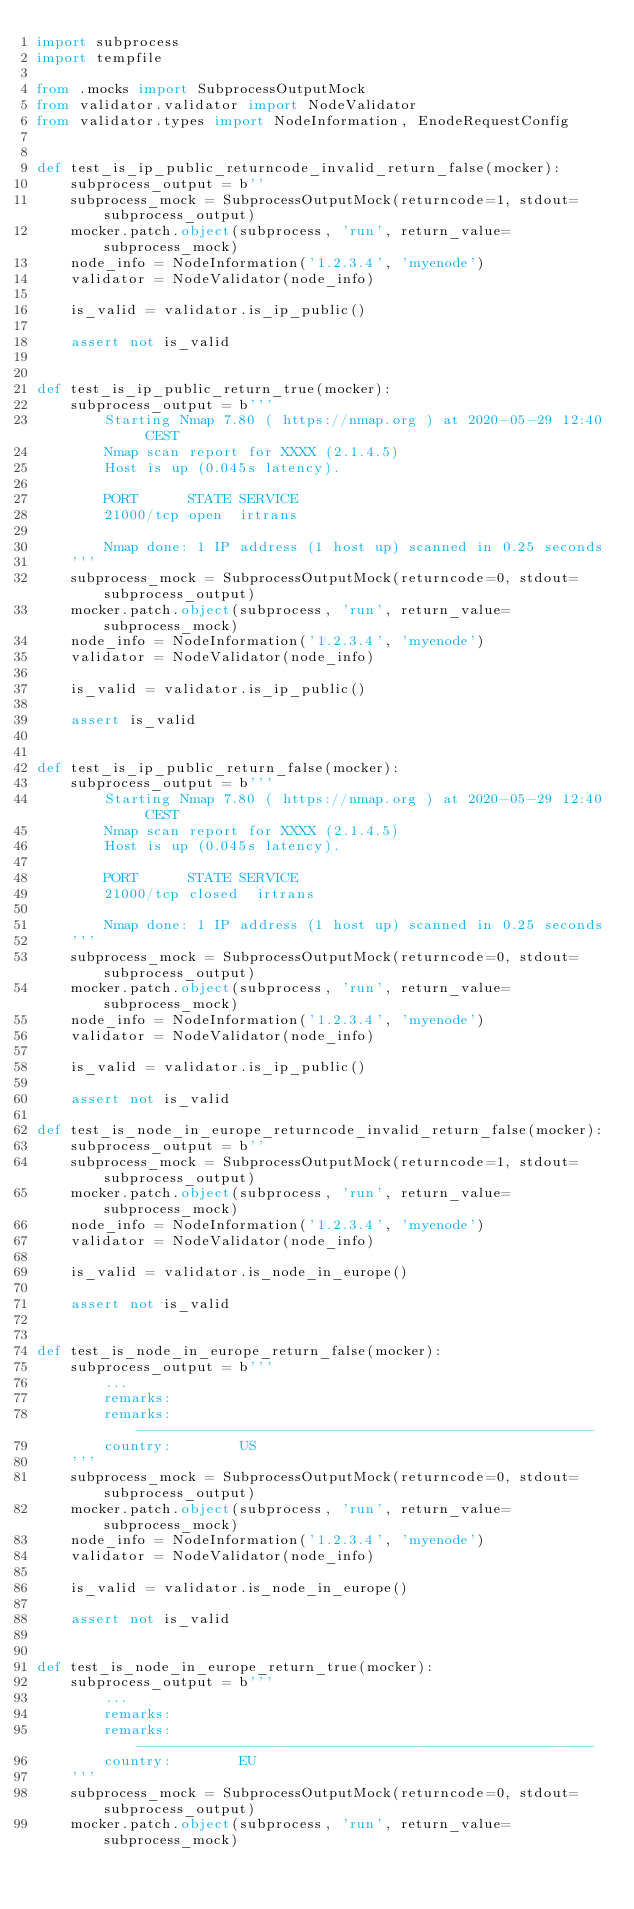Convert code to text. <code><loc_0><loc_0><loc_500><loc_500><_Python_>import subprocess
import tempfile

from .mocks import SubprocessOutputMock
from validator.validator import NodeValidator
from validator.types import NodeInformation, EnodeRequestConfig


def test_is_ip_public_returncode_invalid_return_false(mocker):
    subprocess_output = b''
    subprocess_mock = SubprocessOutputMock(returncode=1, stdout=subprocess_output)
    mocker.patch.object(subprocess, 'run', return_value=subprocess_mock)
    node_info = NodeInformation('1.2.3.4', 'myenode')
    validator = NodeValidator(node_info)

    is_valid = validator.is_ip_public()

    assert not is_valid


def test_is_ip_public_return_true(mocker):
    subprocess_output = b'''
        Starting Nmap 7.80 ( https://nmap.org ) at 2020-05-29 12:40 CEST
        Nmap scan report for XXXX (2.1.4.5)
        Host is up (0.045s latency).

        PORT      STATE SERVICE
        21000/tcp open  irtrans

        Nmap done: 1 IP address (1 host up) scanned in 0.25 seconds
    '''
    subprocess_mock = SubprocessOutputMock(returncode=0, stdout=subprocess_output)
    mocker.patch.object(subprocess, 'run', return_value=subprocess_mock)
    node_info = NodeInformation('1.2.3.4', 'myenode')
    validator = NodeValidator(node_info)

    is_valid = validator.is_ip_public()

    assert is_valid


def test_is_ip_public_return_false(mocker):
    subprocess_output = b'''
        Starting Nmap 7.80 ( https://nmap.org ) at 2020-05-29 12:40 CEST
        Nmap scan report for XXXX (2.1.4.5)
        Host is up (0.045s latency).

        PORT      STATE SERVICE
        21000/tcp closed  irtrans

        Nmap done: 1 IP address (1 host up) scanned in 0.25 seconds
    '''
    subprocess_mock = SubprocessOutputMock(returncode=0, stdout=subprocess_output)
    mocker.patch.object(subprocess, 'run', return_value=subprocess_mock)
    node_info = NodeInformation('1.2.3.4', 'myenode')
    validator = NodeValidator(node_info)

    is_valid = validator.is_ip_public()

    assert not is_valid

def test_is_node_in_europe_returncode_invalid_return_false(mocker):
    subprocess_output = b''
    subprocess_mock = SubprocessOutputMock(returncode=1, stdout=subprocess_output)
    mocker.patch.object(subprocess, 'run', return_value=subprocess_mock)
    node_info = NodeInformation('1.2.3.4', 'myenode')
    validator = NodeValidator(node_info)

    is_valid = validator.is_node_in_europe()

    assert not is_valid


def test_is_node_in_europe_return_false(mocker):
    subprocess_output = b'''
        ...
        remarks:
        remarks:        ------------------------------------------------------
        country:        US
    '''
    subprocess_mock = SubprocessOutputMock(returncode=0, stdout=subprocess_output)
    mocker.patch.object(subprocess, 'run', return_value=subprocess_mock)
    node_info = NodeInformation('1.2.3.4', 'myenode')
    validator = NodeValidator(node_info)

    is_valid = validator.is_node_in_europe()

    assert not is_valid


def test_is_node_in_europe_return_true(mocker):
    subprocess_output = b'''
        ...
        remarks:
        remarks:        ------------------------------------------------------
        country:        EU
    '''
    subprocess_mock = SubprocessOutputMock(returncode=0, stdout=subprocess_output)
    mocker.patch.object(subprocess, 'run', return_value=subprocess_mock)</code> 